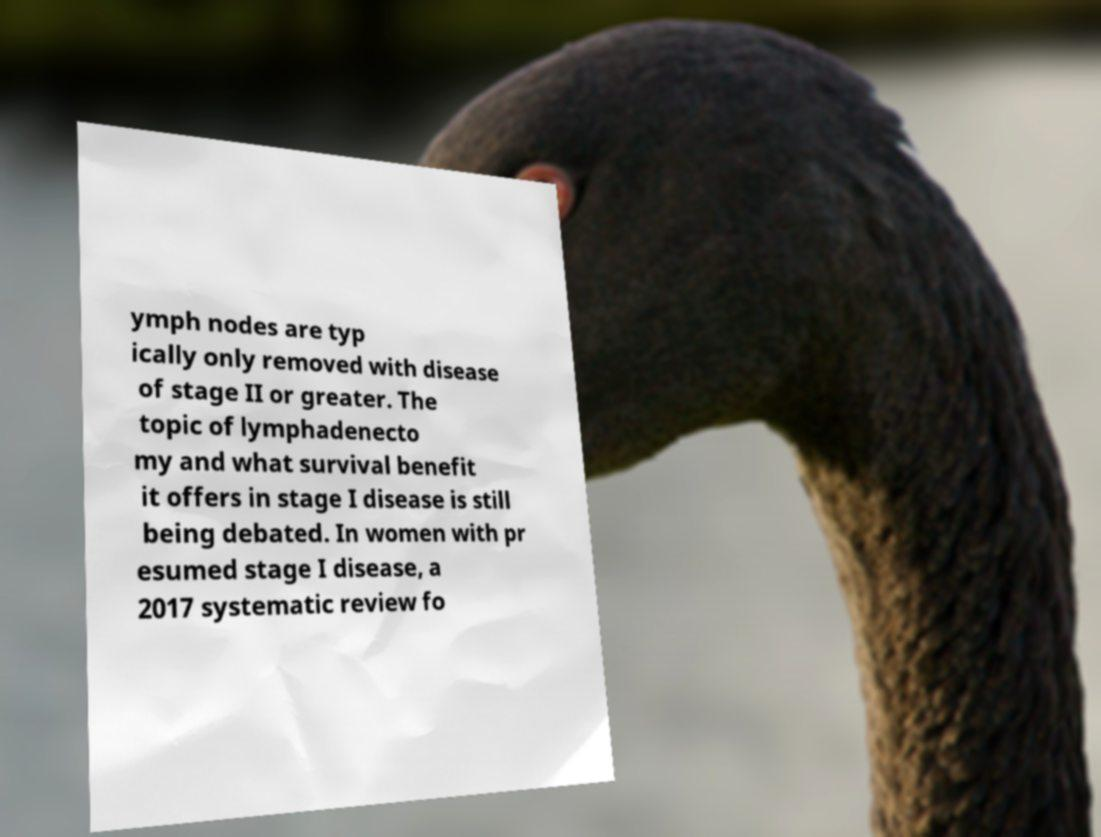There's text embedded in this image that I need extracted. Can you transcribe it verbatim? ymph nodes are typ ically only removed with disease of stage II or greater. The topic of lymphadenecto my and what survival benefit it offers in stage I disease is still being debated. In women with pr esumed stage I disease, a 2017 systematic review fo 